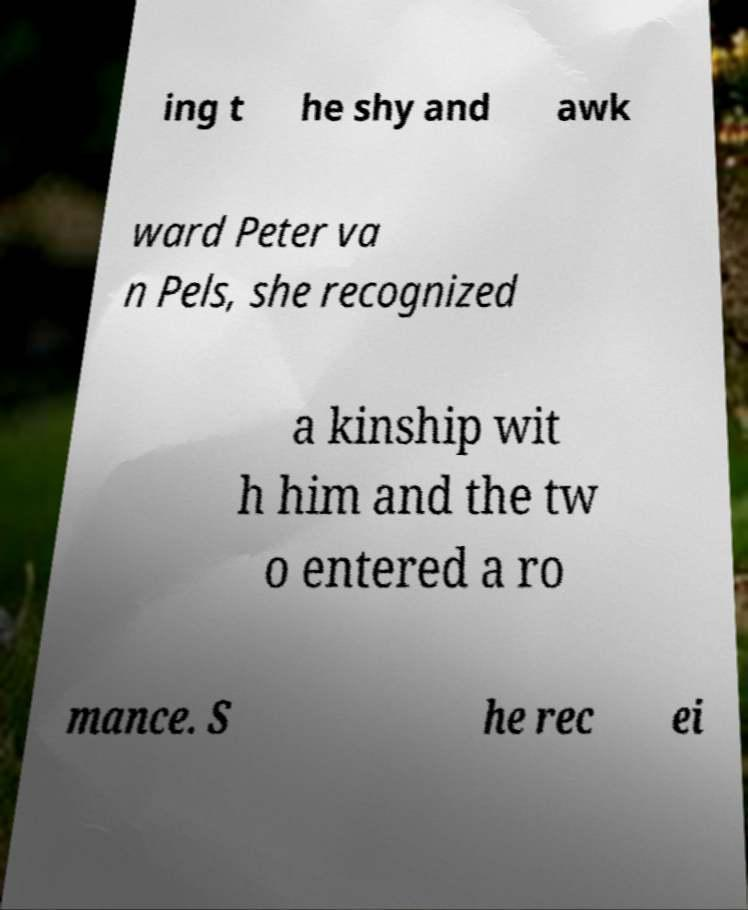Please identify and transcribe the text found in this image. ing t he shy and awk ward Peter va n Pels, she recognized a kinship wit h him and the tw o entered a ro mance. S he rec ei 